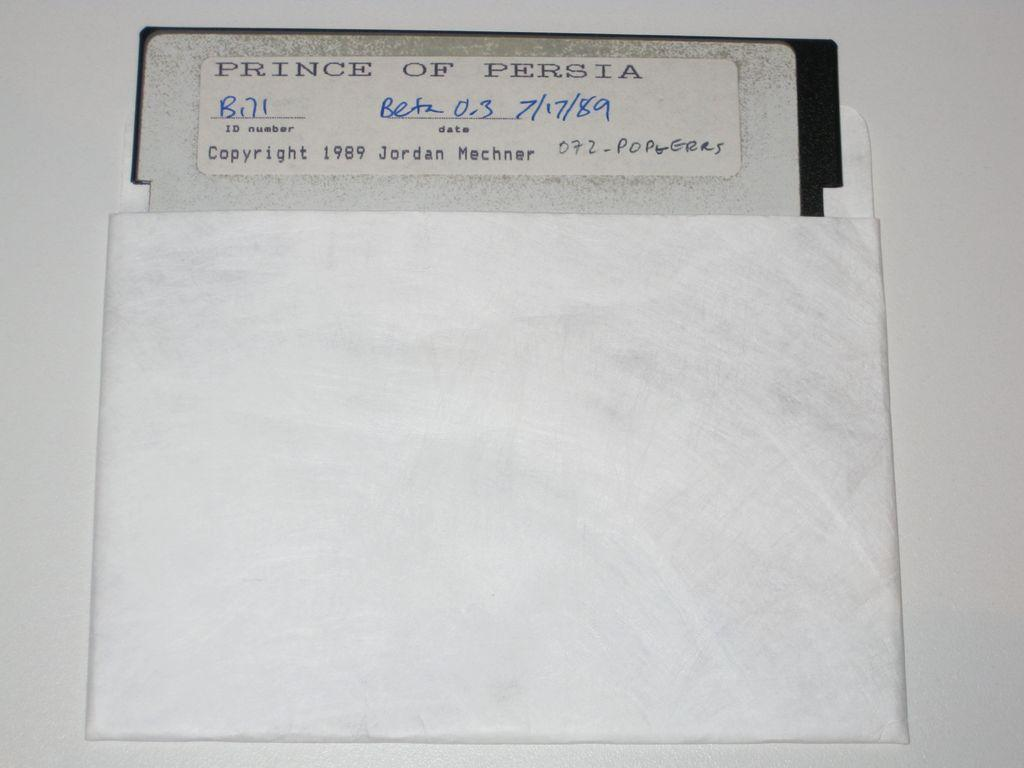Provide a one-sentence caption for the provided image. An old sleeved floppy disc from 1989 for Prince of Persia software. 